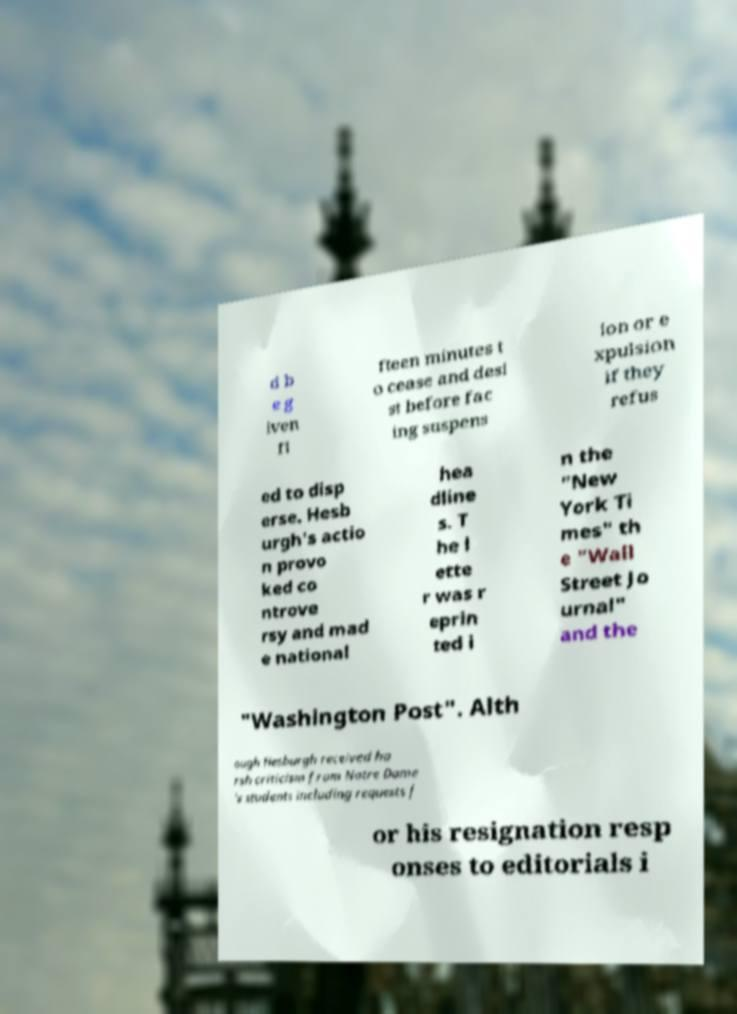For documentation purposes, I need the text within this image transcribed. Could you provide that? d b e g iven fi fteen minutes t o cease and desi st before fac ing suspens ion or e xpulsion if they refus ed to disp erse. Hesb urgh's actio n provo ked co ntrove rsy and mad e national hea dline s. T he l ette r was r eprin ted i n the "New York Ti mes" th e "Wall Street Jo urnal" and the "Washington Post". Alth ough Hesburgh received ha rsh criticism from Notre Dame 's students including requests f or his resignation resp onses to editorials i 